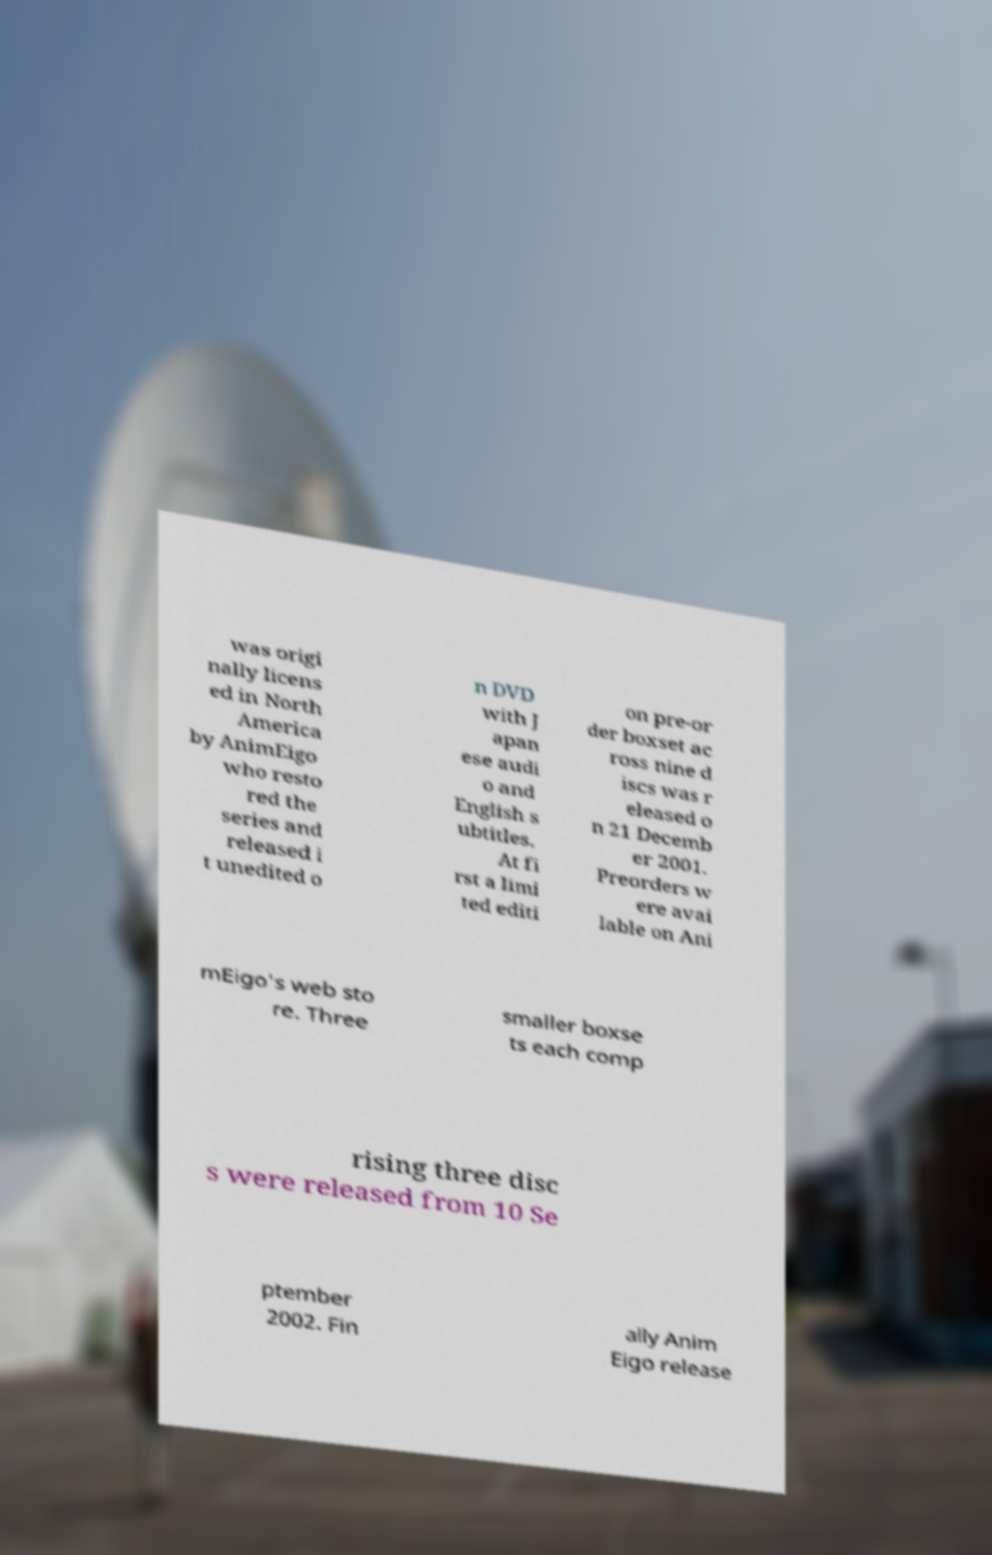Could you extract and type out the text from this image? was origi nally licens ed in North America by AnimEigo who resto red the series and released i t unedited o n DVD with J apan ese audi o and English s ubtitles. At fi rst a limi ted editi on pre-or der boxset ac ross nine d iscs was r eleased o n 21 Decemb er 2001. Preorders w ere avai lable on Ani mEigo's web sto re. Three smaller boxse ts each comp rising three disc s were released from 10 Se ptember 2002. Fin ally Anim Eigo release 